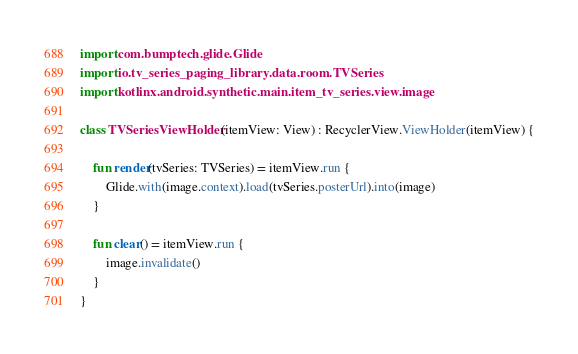Convert code to text. <code><loc_0><loc_0><loc_500><loc_500><_Kotlin_>import com.bumptech.glide.Glide
import io.tv_series_paging_library.data.room.TVSeries
import kotlinx.android.synthetic.main.item_tv_series.view.image

class TVSeriesViewHolder(itemView: View) : RecyclerView.ViewHolder(itemView) {

    fun render(tvSeries: TVSeries) = itemView.run {
        Glide.with(image.context).load(tvSeries.posterUrl).into(image)
    }

    fun clear() = itemView.run {
        image.invalidate()
    }
}
</code> 